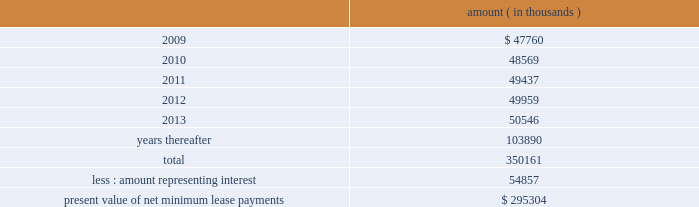Entergy corporation and subsidiaries notes to financial statements as of december 31 , 2008 , system energy had future minimum lease payments ( reflecting an implicit rate of 5.13% ( 5.13 % ) ) , which are recorded as long-term debt as follows : amount ( in thousands ) .

What percent of lease payments are due after 2013? 
Computations: (103890 / 350161)
Answer: 0.29669. 